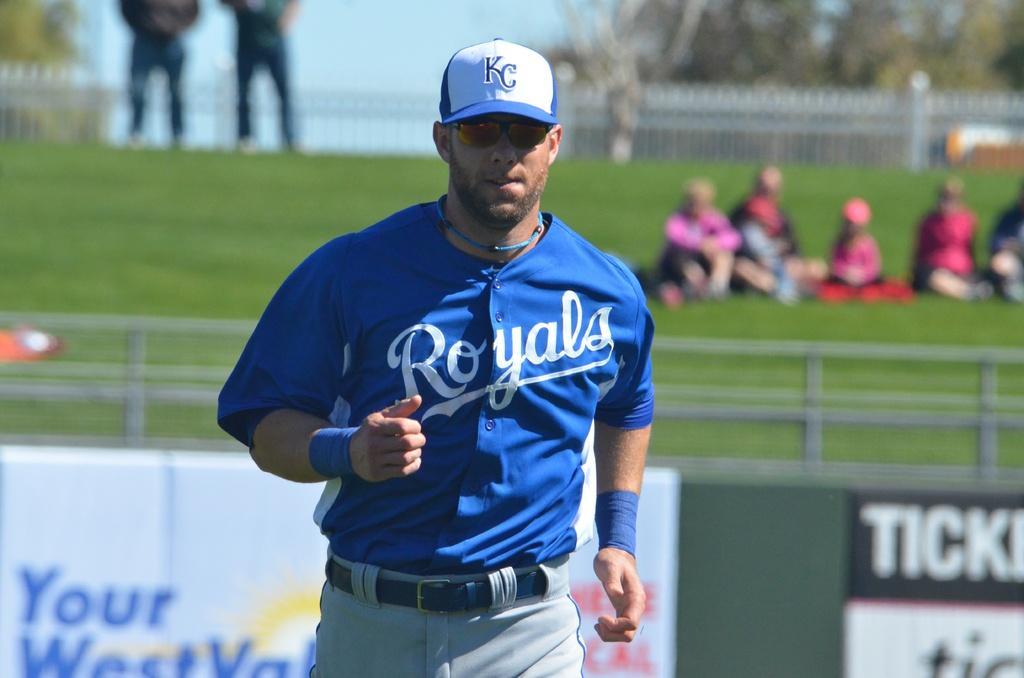Could you give a brief overview of what you see in this image? In this image there is a man, he is wearing a cap, spects, blue shirt, blue bands and gray pant, and standing in a ground, in the background it is blurred. 